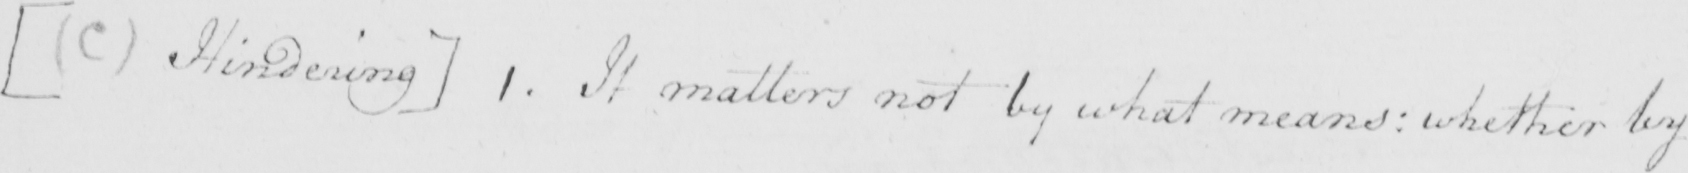What is written in this line of handwriting? [  ( C )  Hindering ]  1 . It matters not by what means :  whether by 